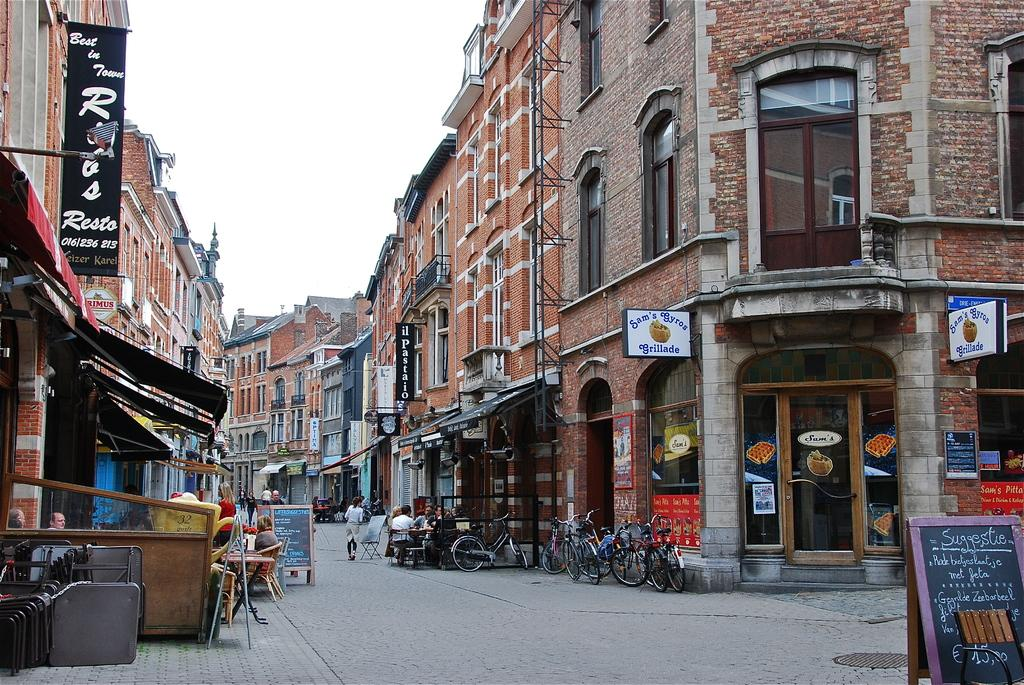What type of structures can be seen in the image? There are buildings in the image. What architectural features are visible on the buildings? There are windows and doors visible on the buildings. What additional objects can be seen in the image? There are boards, banners, bicycles, and people sitting on chairs in the image. What is the color of the sky in the image? The sky appears to be white in color. What type of oil is being used to lubricate the desk in the image? There is no desk present in the image, so there is no oil being used to lubricate it. 